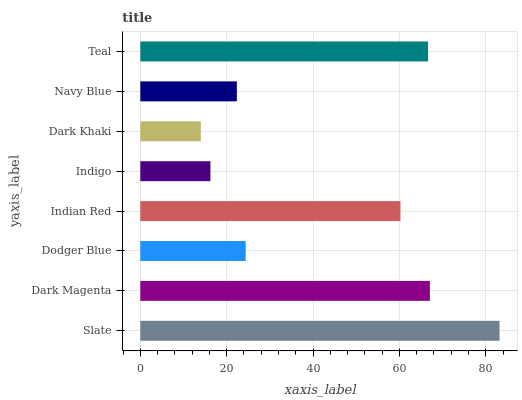Is Dark Khaki the minimum?
Answer yes or no. Yes. Is Slate the maximum?
Answer yes or no. Yes. Is Dark Magenta the minimum?
Answer yes or no. No. Is Dark Magenta the maximum?
Answer yes or no. No. Is Slate greater than Dark Magenta?
Answer yes or no. Yes. Is Dark Magenta less than Slate?
Answer yes or no. Yes. Is Dark Magenta greater than Slate?
Answer yes or no. No. Is Slate less than Dark Magenta?
Answer yes or no. No. Is Indian Red the high median?
Answer yes or no. Yes. Is Dodger Blue the low median?
Answer yes or no. Yes. Is Navy Blue the high median?
Answer yes or no. No. Is Teal the low median?
Answer yes or no. No. 